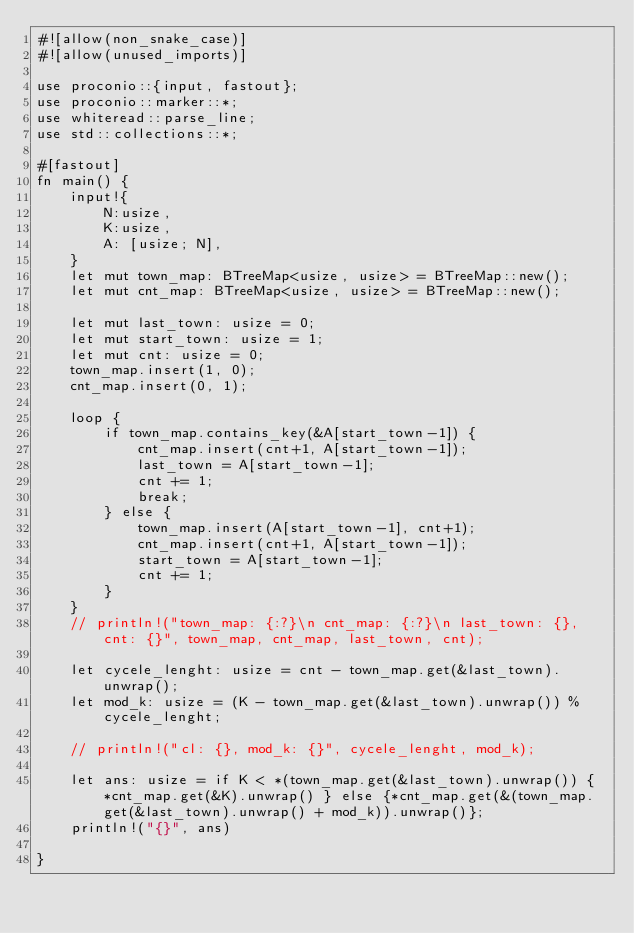Convert code to text. <code><loc_0><loc_0><loc_500><loc_500><_Rust_>#![allow(non_snake_case)]
#![allow(unused_imports)]
 
use proconio::{input, fastout};
use proconio::marker::*;
use whiteread::parse_line;
use std::collections::*;

#[fastout]
fn main() {
    input!{
        N:usize,
        K:usize,
        A: [usize; N],
    }
    let mut town_map: BTreeMap<usize, usize> = BTreeMap::new();
    let mut cnt_map: BTreeMap<usize, usize> = BTreeMap::new();
    
    let mut last_town: usize = 0;
    let mut start_town: usize = 1;
    let mut cnt: usize = 0;
    town_map.insert(1, 0);
    cnt_map.insert(0, 1);

    loop {
        if town_map.contains_key(&A[start_town-1]) {
            cnt_map.insert(cnt+1, A[start_town-1]);
            last_town = A[start_town-1];
            cnt += 1;
            break;
        } else {
            town_map.insert(A[start_town-1], cnt+1);
            cnt_map.insert(cnt+1, A[start_town-1]);
            start_town = A[start_town-1];
            cnt += 1;
        }
    }
    // println!("town_map: {:?}\n cnt_map: {:?}\n last_town: {}, cnt: {}", town_map, cnt_map, last_town, cnt);

    let cycele_lenght: usize = cnt - town_map.get(&last_town).unwrap();
    let mod_k: usize = (K - town_map.get(&last_town).unwrap()) % cycele_lenght;

    // println!("cl: {}, mod_k: {}", cycele_lenght, mod_k);

    let ans: usize = if K < *(town_map.get(&last_town).unwrap()) { *cnt_map.get(&K).unwrap() } else {*cnt_map.get(&(town_map.get(&last_town).unwrap() + mod_k)).unwrap()};
    println!("{}", ans)
    
}
</code> 